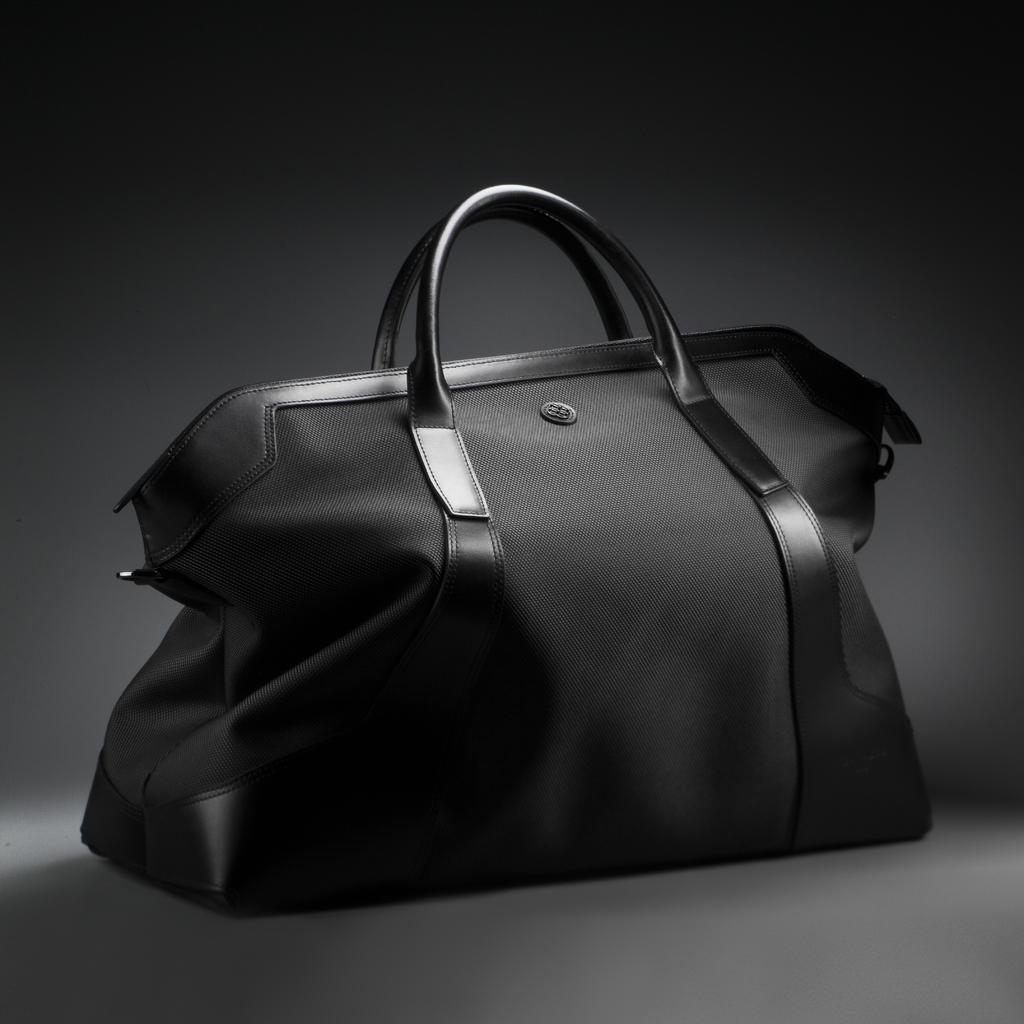Could you give a brief overview of what you see in this image? This is the picture of a black color handbag. 